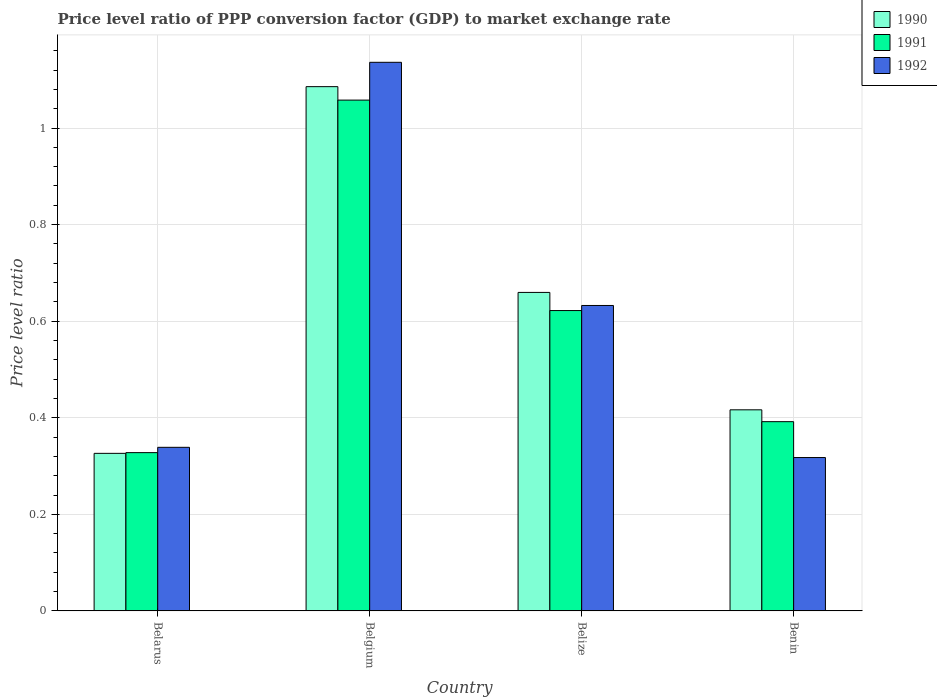How many groups of bars are there?
Ensure brevity in your answer.  4. Are the number of bars per tick equal to the number of legend labels?
Provide a succinct answer. Yes. How many bars are there on the 4th tick from the left?
Offer a very short reply. 3. How many bars are there on the 3rd tick from the right?
Offer a very short reply. 3. What is the label of the 3rd group of bars from the left?
Provide a succinct answer. Belize. What is the price level ratio in 1990 in Belarus?
Provide a short and direct response. 0.33. Across all countries, what is the maximum price level ratio in 1991?
Your answer should be very brief. 1.06. Across all countries, what is the minimum price level ratio in 1991?
Offer a terse response. 0.33. In which country was the price level ratio in 1990 minimum?
Give a very brief answer. Belarus. What is the total price level ratio in 1990 in the graph?
Offer a very short reply. 2.49. What is the difference between the price level ratio in 1992 in Belgium and that in Belize?
Provide a short and direct response. 0.5. What is the difference between the price level ratio in 1992 in Belize and the price level ratio in 1991 in Belarus?
Your answer should be very brief. 0.3. What is the average price level ratio in 1991 per country?
Provide a short and direct response. 0.6. What is the difference between the price level ratio of/in 1991 and price level ratio of/in 1990 in Belarus?
Offer a very short reply. 0. In how many countries, is the price level ratio in 1990 greater than 0.36?
Your answer should be compact. 3. What is the ratio of the price level ratio in 1991 in Belgium to that in Benin?
Provide a succinct answer. 2.7. Is the price level ratio in 1991 in Belarus less than that in Belize?
Keep it short and to the point. Yes. Is the difference between the price level ratio in 1991 in Belarus and Belgium greater than the difference between the price level ratio in 1990 in Belarus and Belgium?
Offer a terse response. Yes. What is the difference between the highest and the second highest price level ratio in 1990?
Your answer should be very brief. -0.43. What is the difference between the highest and the lowest price level ratio in 1990?
Your response must be concise. 0.76. In how many countries, is the price level ratio in 1990 greater than the average price level ratio in 1990 taken over all countries?
Provide a short and direct response. 2. Is it the case that in every country, the sum of the price level ratio in 1990 and price level ratio in 1991 is greater than the price level ratio in 1992?
Your answer should be compact. Yes. How many bars are there?
Ensure brevity in your answer.  12. Are all the bars in the graph horizontal?
Give a very brief answer. No. Does the graph contain any zero values?
Give a very brief answer. No. Where does the legend appear in the graph?
Your answer should be very brief. Top right. What is the title of the graph?
Your response must be concise. Price level ratio of PPP conversion factor (GDP) to market exchange rate. Does "1982" appear as one of the legend labels in the graph?
Offer a very short reply. No. What is the label or title of the Y-axis?
Provide a short and direct response. Price level ratio. What is the Price level ratio of 1990 in Belarus?
Ensure brevity in your answer.  0.33. What is the Price level ratio in 1991 in Belarus?
Provide a short and direct response. 0.33. What is the Price level ratio of 1992 in Belarus?
Provide a succinct answer. 0.34. What is the Price level ratio in 1990 in Belgium?
Offer a terse response. 1.09. What is the Price level ratio in 1991 in Belgium?
Keep it short and to the point. 1.06. What is the Price level ratio in 1992 in Belgium?
Provide a succinct answer. 1.14. What is the Price level ratio in 1990 in Belize?
Offer a very short reply. 0.66. What is the Price level ratio in 1991 in Belize?
Provide a succinct answer. 0.62. What is the Price level ratio in 1992 in Belize?
Offer a terse response. 0.63. What is the Price level ratio in 1990 in Benin?
Give a very brief answer. 0.42. What is the Price level ratio in 1991 in Benin?
Provide a succinct answer. 0.39. What is the Price level ratio in 1992 in Benin?
Offer a terse response. 0.32. Across all countries, what is the maximum Price level ratio of 1990?
Your response must be concise. 1.09. Across all countries, what is the maximum Price level ratio in 1991?
Your answer should be compact. 1.06. Across all countries, what is the maximum Price level ratio of 1992?
Offer a terse response. 1.14. Across all countries, what is the minimum Price level ratio in 1990?
Keep it short and to the point. 0.33. Across all countries, what is the minimum Price level ratio in 1991?
Give a very brief answer. 0.33. Across all countries, what is the minimum Price level ratio of 1992?
Your response must be concise. 0.32. What is the total Price level ratio in 1990 in the graph?
Make the answer very short. 2.49. What is the total Price level ratio of 1991 in the graph?
Offer a terse response. 2.4. What is the total Price level ratio of 1992 in the graph?
Your answer should be compact. 2.43. What is the difference between the Price level ratio of 1990 in Belarus and that in Belgium?
Offer a very short reply. -0.76. What is the difference between the Price level ratio of 1991 in Belarus and that in Belgium?
Provide a succinct answer. -0.73. What is the difference between the Price level ratio in 1992 in Belarus and that in Belgium?
Your answer should be compact. -0.8. What is the difference between the Price level ratio in 1991 in Belarus and that in Belize?
Keep it short and to the point. -0.29. What is the difference between the Price level ratio of 1992 in Belarus and that in Belize?
Offer a very short reply. -0.29. What is the difference between the Price level ratio in 1990 in Belarus and that in Benin?
Your answer should be very brief. -0.09. What is the difference between the Price level ratio in 1991 in Belarus and that in Benin?
Provide a short and direct response. -0.06. What is the difference between the Price level ratio in 1992 in Belarus and that in Benin?
Your response must be concise. 0.02. What is the difference between the Price level ratio in 1990 in Belgium and that in Belize?
Keep it short and to the point. 0.43. What is the difference between the Price level ratio of 1991 in Belgium and that in Belize?
Your answer should be very brief. 0.44. What is the difference between the Price level ratio of 1992 in Belgium and that in Belize?
Your answer should be very brief. 0.5. What is the difference between the Price level ratio in 1990 in Belgium and that in Benin?
Give a very brief answer. 0.67. What is the difference between the Price level ratio in 1991 in Belgium and that in Benin?
Your answer should be very brief. 0.67. What is the difference between the Price level ratio of 1992 in Belgium and that in Benin?
Give a very brief answer. 0.82. What is the difference between the Price level ratio of 1990 in Belize and that in Benin?
Your answer should be compact. 0.24. What is the difference between the Price level ratio in 1991 in Belize and that in Benin?
Offer a terse response. 0.23. What is the difference between the Price level ratio of 1992 in Belize and that in Benin?
Your answer should be compact. 0.31. What is the difference between the Price level ratio of 1990 in Belarus and the Price level ratio of 1991 in Belgium?
Keep it short and to the point. -0.73. What is the difference between the Price level ratio of 1990 in Belarus and the Price level ratio of 1992 in Belgium?
Keep it short and to the point. -0.81. What is the difference between the Price level ratio in 1991 in Belarus and the Price level ratio in 1992 in Belgium?
Ensure brevity in your answer.  -0.81. What is the difference between the Price level ratio of 1990 in Belarus and the Price level ratio of 1991 in Belize?
Make the answer very short. -0.3. What is the difference between the Price level ratio of 1990 in Belarus and the Price level ratio of 1992 in Belize?
Provide a short and direct response. -0.31. What is the difference between the Price level ratio in 1991 in Belarus and the Price level ratio in 1992 in Belize?
Provide a succinct answer. -0.3. What is the difference between the Price level ratio in 1990 in Belarus and the Price level ratio in 1991 in Benin?
Provide a succinct answer. -0.07. What is the difference between the Price level ratio of 1990 in Belarus and the Price level ratio of 1992 in Benin?
Your answer should be compact. 0.01. What is the difference between the Price level ratio of 1991 in Belarus and the Price level ratio of 1992 in Benin?
Keep it short and to the point. 0.01. What is the difference between the Price level ratio of 1990 in Belgium and the Price level ratio of 1991 in Belize?
Your answer should be very brief. 0.46. What is the difference between the Price level ratio in 1990 in Belgium and the Price level ratio in 1992 in Belize?
Offer a very short reply. 0.45. What is the difference between the Price level ratio of 1991 in Belgium and the Price level ratio of 1992 in Belize?
Provide a short and direct response. 0.43. What is the difference between the Price level ratio in 1990 in Belgium and the Price level ratio in 1991 in Benin?
Give a very brief answer. 0.69. What is the difference between the Price level ratio in 1990 in Belgium and the Price level ratio in 1992 in Benin?
Give a very brief answer. 0.77. What is the difference between the Price level ratio in 1991 in Belgium and the Price level ratio in 1992 in Benin?
Your response must be concise. 0.74. What is the difference between the Price level ratio in 1990 in Belize and the Price level ratio in 1991 in Benin?
Your answer should be very brief. 0.27. What is the difference between the Price level ratio of 1990 in Belize and the Price level ratio of 1992 in Benin?
Make the answer very short. 0.34. What is the difference between the Price level ratio in 1991 in Belize and the Price level ratio in 1992 in Benin?
Ensure brevity in your answer.  0.3. What is the average Price level ratio of 1990 per country?
Provide a short and direct response. 0.62. What is the average Price level ratio in 1991 per country?
Make the answer very short. 0.6. What is the average Price level ratio in 1992 per country?
Ensure brevity in your answer.  0.61. What is the difference between the Price level ratio in 1990 and Price level ratio in 1991 in Belarus?
Offer a terse response. -0. What is the difference between the Price level ratio in 1990 and Price level ratio in 1992 in Belarus?
Provide a succinct answer. -0.01. What is the difference between the Price level ratio in 1991 and Price level ratio in 1992 in Belarus?
Give a very brief answer. -0.01. What is the difference between the Price level ratio of 1990 and Price level ratio of 1991 in Belgium?
Your answer should be very brief. 0.03. What is the difference between the Price level ratio in 1990 and Price level ratio in 1992 in Belgium?
Offer a very short reply. -0.05. What is the difference between the Price level ratio in 1991 and Price level ratio in 1992 in Belgium?
Ensure brevity in your answer.  -0.08. What is the difference between the Price level ratio in 1990 and Price level ratio in 1991 in Belize?
Provide a short and direct response. 0.04. What is the difference between the Price level ratio in 1990 and Price level ratio in 1992 in Belize?
Provide a succinct answer. 0.03. What is the difference between the Price level ratio in 1991 and Price level ratio in 1992 in Belize?
Keep it short and to the point. -0.01. What is the difference between the Price level ratio in 1990 and Price level ratio in 1991 in Benin?
Provide a succinct answer. 0.02. What is the difference between the Price level ratio in 1990 and Price level ratio in 1992 in Benin?
Ensure brevity in your answer.  0.1. What is the difference between the Price level ratio of 1991 and Price level ratio of 1992 in Benin?
Keep it short and to the point. 0.07. What is the ratio of the Price level ratio in 1990 in Belarus to that in Belgium?
Provide a short and direct response. 0.3. What is the ratio of the Price level ratio in 1991 in Belarus to that in Belgium?
Keep it short and to the point. 0.31. What is the ratio of the Price level ratio in 1992 in Belarus to that in Belgium?
Your answer should be compact. 0.3. What is the ratio of the Price level ratio in 1990 in Belarus to that in Belize?
Give a very brief answer. 0.49. What is the ratio of the Price level ratio in 1991 in Belarus to that in Belize?
Offer a terse response. 0.53. What is the ratio of the Price level ratio in 1992 in Belarus to that in Belize?
Your answer should be very brief. 0.54. What is the ratio of the Price level ratio of 1990 in Belarus to that in Benin?
Keep it short and to the point. 0.78. What is the ratio of the Price level ratio of 1991 in Belarus to that in Benin?
Your response must be concise. 0.84. What is the ratio of the Price level ratio in 1992 in Belarus to that in Benin?
Offer a terse response. 1.07. What is the ratio of the Price level ratio in 1990 in Belgium to that in Belize?
Provide a short and direct response. 1.65. What is the ratio of the Price level ratio in 1991 in Belgium to that in Belize?
Your response must be concise. 1.7. What is the ratio of the Price level ratio in 1992 in Belgium to that in Belize?
Make the answer very short. 1.8. What is the ratio of the Price level ratio in 1990 in Belgium to that in Benin?
Ensure brevity in your answer.  2.61. What is the ratio of the Price level ratio of 1991 in Belgium to that in Benin?
Provide a short and direct response. 2.7. What is the ratio of the Price level ratio in 1992 in Belgium to that in Benin?
Offer a terse response. 3.58. What is the ratio of the Price level ratio of 1990 in Belize to that in Benin?
Offer a very short reply. 1.58. What is the ratio of the Price level ratio of 1991 in Belize to that in Benin?
Keep it short and to the point. 1.59. What is the ratio of the Price level ratio in 1992 in Belize to that in Benin?
Your answer should be compact. 1.99. What is the difference between the highest and the second highest Price level ratio in 1990?
Provide a succinct answer. 0.43. What is the difference between the highest and the second highest Price level ratio in 1991?
Offer a terse response. 0.44. What is the difference between the highest and the second highest Price level ratio of 1992?
Your answer should be very brief. 0.5. What is the difference between the highest and the lowest Price level ratio in 1990?
Offer a terse response. 0.76. What is the difference between the highest and the lowest Price level ratio in 1991?
Your answer should be compact. 0.73. What is the difference between the highest and the lowest Price level ratio in 1992?
Make the answer very short. 0.82. 